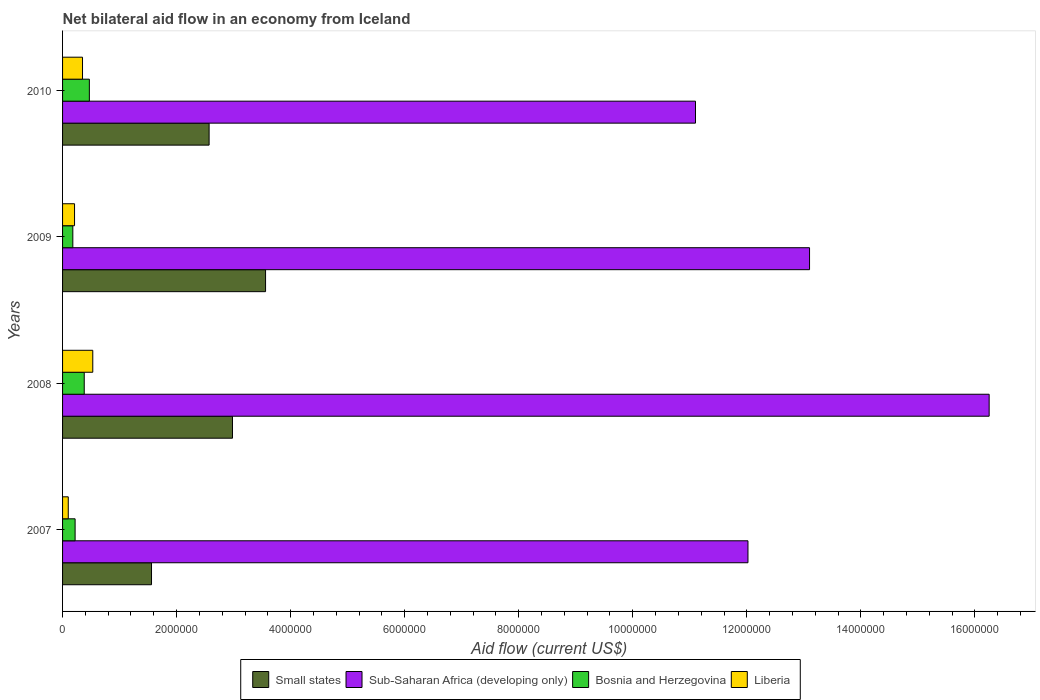How many different coloured bars are there?
Your response must be concise. 4. How many groups of bars are there?
Keep it short and to the point. 4. Are the number of bars per tick equal to the number of legend labels?
Provide a succinct answer. Yes. How many bars are there on the 2nd tick from the bottom?
Provide a short and direct response. 4. What is the net bilateral aid flow in Liberia in 2007?
Keep it short and to the point. 1.00e+05. Across all years, what is the minimum net bilateral aid flow in Sub-Saharan Africa (developing only)?
Your answer should be very brief. 1.11e+07. In which year was the net bilateral aid flow in Bosnia and Herzegovina minimum?
Make the answer very short. 2009. What is the total net bilateral aid flow in Bosnia and Herzegovina in the graph?
Give a very brief answer. 1.25e+06. What is the difference between the net bilateral aid flow in Liberia in 2008 and that in 2009?
Ensure brevity in your answer.  3.20e+05. What is the difference between the net bilateral aid flow in Small states in 2010 and the net bilateral aid flow in Sub-Saharan Africa (developing only) in 2007?
Offer a very short reply. -9.45e+06. What is the average net bilateral aid flow in Small states per year?
Give a very brief answer. 2.67e+06. In the year 2009, what is the difference between the net bilateral aid flow in Sub-Saharan Africa (developing only) and net bilateral aid flow in Bosnia and Herzegovina?
Offer a very short reply. 1.29e+07. In how many years, is the net bilateral aid flow in Small states greater than 10400000 US$?
Offer a terse response. 0. What is the ratio of the net bilateral aid flow in Liberia in 2008 to that in 2009?
Ensure brevity in your answer.  2.52. What is the difference between the highest and the lowest net bilateral aid flow in Sub-Saharan Africa (developing only)?
Offer a very short reply. 5.15e+06. In how many years, is the net bilateral aid flow in Sub-Saharan Africa (developing only) greater than the average net bilateral aid flow in Sub-Saharan Africa (developing only) taken over all years?
Provide a succinct answer. 1. Is it the case that in every year, the sum of the net bilateral aid flow in Liberia and net bilateral aid flow in Small states is greater than the sum of net bilateral aid flow in Bosnia and Herzegovina and net bilateral aid flow in Sub-Saharan Africa (developing only)?
Provide a succinct answer. Yes. What does the 3rd bar from the top in 2010 represents?
Your answer should be compact. Sub-Saharan Africa (developing only). What does the 2nd bar from the bottom in 2009 represents?
Keep it short and to the point. Sub-Saharan Africa (developing only). How many bars are there?
Make the answer very short. 16. Are all the bars in the graph horizontal?
Ensure brevity in your answer.  Yes. How many years are there in the graph?
Ensure brevity in your answer.  4. Are the values on the major ticks of X-axis written in scientific E-notation?
Keep it short and to the point. No. Does the graph contain any zero values?
Make the answer very short. No. Where does the legend appear in the graph?
Your answer should be very brief. Bottom center. What is the title of the graph?
Provide a short and direct response. Net bilateral aid flow in an economy from Iceland. What is the label or title of the Y-axis?
Give a very brief answer. Years. What is the Aid flow (current US$) in Small states in 2007?
Provide a succinct answer. 1.56e+06. What is the Aid flow (current US$) in Sub-Saharan Africa (developing only) in 2007?
Provide a short and direct response. 1.20e+07. What is the Aid flow (current US$) in Bosnia and Herzegovina in 2007?
Offer a terse response. 2.20e+05. What is the Aid flow (current US$) in Small states in 2008?
Keep it short and to the point. 2.98e+06. What is the Aid flow (current US$) of Sub-Saharan Africa (developing only) in 2008?
Provide a succinct answer. 1.62e+07. What is the Aid flow (current US$) in Bosnia and Herzegovina in 2008?
Provide a short and direct response. 3.80e+05. What is the Aid flow (current US$) of Liberia in 2008?
Your answer should be very brief. 5.30e+05. What is the Aid flow (current US$) of Small states in 2009?
Keep it short and to the point. 3.56e+06. What is the Aid flow (current US$) of Sub-Saharan Africa (developing only) in 2009?
Your answer should be compact. 1.31e+07. What is the Aid flow (current US$) in Liberia in 2009?
Your answer should be compact. 2.10e+05. What is the Aid flow (current US$) of Small states in 2010?
Your answer should be compact. 2.57e+06. What is the Aid flow (current US$) in Sub-Saharan Africa (developing only) in 2010?
Offer a very short reply. 1.11e+07. What is the Aid flow (current US$) in Bosnia and Herzegovina in 2010?
Provide a short and direct response. 4.70e+05. What is the Aid flow (current US$) of Liberia in 2010?
Your response must be concise. 3.50e+05. Across all years, what is the maximum Aid flow (current US$) in Small states?
Provide a short and direct response. 3.56e+06. Across all years, what is the maximum Aid flow (current US$) of Sub-Saharan Africa (developing only)?
Your answer should be very brief. 1.62e+07. Across all years, what is the maximum Aid flow (current US$) in Liberia?
Provide a succinct answer. 5.30e+05. Across all years, what is the minimum Aid flow (current US$) in Small states?
Offer a very short reply. 1.56e+06. Across all years, what is the minimum Aid flow (current US$) in Sub-Saharan Africa (developing only)?
Offer a terse response. 1.11e+07. Across all years, what is the minimum Aid flow (current US$) in Bosnia and Herzegovina?
Your answer should be very brief. 1.80e+05. Across all years, what is the minimum Aid flow (current US$) of Liberia?
Provide a short and direct response. 1.00e+05. What is the total Aid flow (current US$) of Small states in the graph?
Your response must be concise. 1.07e+07. What is the total Aid flow (current US$) of Sub-Saharan Africa (developing only) in the graph?
Offer a terse response. 5.25e+07. What is the total Aid flow (current US$) in Bosnia and Herzegovina in the graph?
Provide a short and direct response. 1.25e+06. What is the total Aid flow (current US$) of Liberia in the graph?
Your response must be concise. 1.19e+06. What is the difference between the Aid flow (current US$) of Small states in 2007 and that in 2008?
Your response must be concise. -1.42e+06. What is the difference between the Aid flow (current US$) in Sub-Saharan Africa (developing only) in 2007 and that in 2008?
Your response must be concise. -4.23e+06. What is the difference between the Aid flow (current US$) of Bosnia and Herzegovina in 2007 and that in 2008?
Your response must be concise. -1.60e+05. What is the difference between the Aid flow (current US$) in Liberia in 2007 and that in 2008?
Your response must be concise. -4.30e+05. What is the difference between the Aid flow (current US$) of Sub-Saharan Africa (developing only) in 2007 and that in 2009?
Your response must be concise. -1.08e+06. What is the difference between the Aid flow (current US$) in Liberia in 2007 and that in 2009?
Provide a short and direct response. -1.10e+05. What is the difference between the Aid flow (current US$) in Small states in 2007 and that in 2010?
Your response must be concise. -1.01e+06. What is the difference between the Aid flow (current US$) of Sub-Saharan Africa (developing only) in 2007 and that in 2010?
Make the answer very short. 9.20e+05. What is the difference between the Aid flow (current US$) of Bosnia and Herzegovina in 2007 and that in 2010?
Offer a very short reply. -2.50e+05. What is the difference between the Aid flow (current US$) of Small states in 2008 and that in 2009?
Provide a succinct answer. -5.80e+05. What is the difference between the Aid flow (current US$) of Sub-Saharan Africa (developing only) in 2008 and that in 2009?
Ensure brevity in your answer.  3.15e+06. What is the difference between the Aid flow (current US$) of Sub-Saharan Africa (developing only) in 2008 and that in 2010?
Offer a very short reply. 5.15e+06. What is the difference between the Aid flow (current US$) of Bosnia and Herzegovina in 2008 and that in 2010?
Make the answer very short. -9.00e+04. What is the difference between the Aid flow (current US$) in Small states in 2009 and that in 2010?
Give a very brief answer. 9.90e+05. What is the difference between the Aid flow (current US$) of Sub-Saharan Africa (developing only) in 2009 and that in 2010?
Provide a succinct answer. 2.00e+06. What is the difference between the Aid flow (current US$) in Small states in 2007 and the Aid flow (current US$) in Sub-Saharan Africa (developing only) in 2008?
Give a very brief answer. -1.47e+07. What is the difference between the Aid flow (current US$) in Small states in 2007 and the Aid flow (current US$) in Bosnia and Herzegovina in 2008?
Offer a terse response. 1.18e+06. What is the difference between the Aid flow (current US$) of Small states in 2007 and the Aid flow (current US$) of Liberia in 2008?
Your answer should be compact. 1.03e+06. What is the difference between the Aid flow (current US$) in Sub-Saharan Africa (developing only) in 2007 and the Aid flow (current US$) in Bosnia and Herzegovina in 2008?
Ensure brevity in your answer.  1.16e+07. What is the difference between the Aid flow (current US$) of Sub-Saharan Africa (developing only) in 2007 and the Aid flow (current US$) of Liberia in 2008?
Your answer should be compact. 1.15e+07. What is the difference between the Aid flow (current US$) in Bosnia and Herzegovina in 2007 and the Aid flow (current US$) in Liberia in 2008?
Provide a succinct answer. -3.10e+05. What is the difference between the Aid flow (current US$) in Small states in 2007 and the Aid flow (current US$) in Sub-Saharan Africa (developing only) in 2009?
Your response must be concise. -1.15e+07. What is the difference between the Aid flow (current US$) in Small states in 2007 and the Aid flow (current US$) in Bosnia and Herzegovina in 2009?
Offer a very short reply. 1.38e+06. What is the difference between the Aid flow (current US$) in Small states in 2007 and the Aid flow (current US$) in Liberia in 2009?
Ensure brevity in your answer.  1.35e+06. What is the difference between the Aid flow (current US$) of Sub-Saharan Africa (developing only) in 2007 and the Aid flow (current US$) of Bosnia and Herzegovina in 2009?
Provide a short and direct response. 1.18e+07. What is the difference between the Aid flow (current US$) of Sub-Saharan Africa (developing only) in 2007 and the Aid flow (current US$) of Liberia in 2009?
Provide a short and direct response. 1.18e+07. What is the difference between the Aid flow (current US$) of Bosnia and Herzegovina in 2007 and the Aid flow (current US$) of Liberia in 2009?
Your answer should be very brief. 10000. What is the difference between the Aid flow (current US$) of Small states in 2007 and the Aid flow (current US$) of Sub-Saharan Africa (developing only) in 2010?
Your response must be concise. -9.54e+06. What is the difference between the Aid flow (current US$) of Small states in 2007 and the Aid flow (current US$) of Bosnia and Herzegovina in 2010?
Give a very brief answer. 1.09e+06. What is the difference between the Aid flow (current US$) in Small states in 2007 and the Aid flow (current US$) in Liberia in 2010?
Make the answer very short. 1.21e+06. What is the difference between the Aid flow (current US$) in Sub-Saharan Africa (developing only) in 2007 and the Aid flow (current US$) in Bosnia and Herzegovina in 2010?
Keep it short and to the point. 1.16e+07. What is the difference between the Aid flow (current US$) in Sub-Saharan Africa (developing only) in 2007 and the Aid flow (current US$) in Liberia in 2010?
Make the answer very short. 1.17e+07. What is the difference between the Aid flow (current US$) in Small states in 2008 and the Aid flow (current US$) in Sub-Saharan Africa (developing only) in 2009?
Give a very brief answer. -1.01e+07. What is the difference between the Aid flow (current US$) of Small states in 2008 and the Aid flow (current US$) of Bosnia and Herzegovina in 2009?
Keep it short and to the point. 2.80e+06. What is the difference between the Aid flow (current US$) in Small states in 2008 and the Aid flow (current US$) in Liberia in 2009?
Your answer should be compact. 2.77e+06. What is the difference between the Aid flow (current US$) in Sub-Saharan Africa (developing only) in 2008 and the Aid flow (current US$) in Bosnia and Herzegovina in 2009?
Keep it short and to the point. 1.61e+07. What is the difference between the Aid flow (current US$) in Sub-Saharan Africa (developing only) in 2008 and the Aid flow (current US$) in Liberia in 2009?
Your response must be concise. 1.60e+07. What is the difference between the Aid flow (current US$) of Small states in 2008 and the Aid flow (current US$) of Sub-Saharan Africa (developing only) in 2010?
Offer a terse response. -8.12e+06. What is the difference between the Aid flow (current US$) of Small states in 2008 and the Aid flow (current US$) of Bosnia and Herzegovina in 2010?
Offer a very short reply. 2.51e+06. What is the difference between the Aid flow (current US$) of Small states in 2008 and the Aid flow (current US$) of Liberia in 2010?
Ensure brevity in your answer.  2.63e+06. What is the difference between the Aid flow (current US$) in Sub-Saharan Africa (developing only) in 2008 and the Aid flow (current US$) in Bosnia and Herzegovina in 2010?
Provide a short and direct response. 1.58e+07. What is the difference between the Aid flow (current US$) in Sub-Saharan Africa (developing only) in 2008 and the Aid flow (current US$) in Liberia in 2010?
Give a very brief answer. 1.59e+07. What is the difference between the Aid flow (current US$) of Small states in 2009 and the Aid flow (current US$) of Sub-Saharan Africa (developing only) in 2010?
Give a very brief answer. -7.54e+06. What is the difference between the Aid flow (current US$) in Small states in 2009 and the Aid flow (current US$) in Bosnia and Herzegovina in 2010?
Your answer should be compact. 3.09e+06. What is the difference between the Aid flow (current US$) in Small states in 2009 and the Aid flow (current US$) in Liberia in 2010?
Your answer should be very brief. 3.21e+06. What is the difference between the Aid flow (current US$) in Sub-Saharan Africa (developing only) in 2009 and the Aid flow (current US$) in Bosnia and Herzegovina in 2010?
Provide a short and direct response. 1.26e+07. What is the difference between the Aid flow (current US$) of Sub-Saharan Africa (developing only) in 2009 and the Aid flow (current US$) of Liberia in 2010?
Your answer should be compact. 1.28e+07. What is the average Aid flow (current US$) of Small states per year?
Offer a very short reply. 2.67e+06. What is the average Aid flow (current US$) of Sub-Saharan Africa (developing only) per year?
Keep it short and to the point. 1.31e+07. What is the average Aid flow (current US$) of Bosnia and Herzegovina per year?
Your response must be concise. 3.12e+05. What is the average Aid flow (current US$) in Liberia per year?
Offer a very short reply. 2.98e+05. In the year 2007, what is the difference between the Aid flow (current US$) of Small states and Aid flow (current US$) of Sub-Saharan Africa (developing only)?
Keep it short and to the point. -1.05e+07. In the year 2007, what is the difference between the Aid flow (current US$) of Small states and Aid flow (current US$) of Bosnia and Herzegovina?
Ensure brevity in your answer.  1.34e+06. In the year 2007, what is the difference between the Aid flow (current US$) of Small states and Aid flow (current US$) of Liberia?
Offer a very short reply. 1.46e+06. In the year 2007, what is the difference between the Aid flow (current US$) of Sub-Saharan Africa (developing only) and Aid flow (current US$) of Bosnia and Herzegovina?
Offer a terse response. 1.18e+07. In the year 2007, what is the difference between the Aid flow (current US$) in Sub-Saharan Africa (developing only) and Aid flow (current US$) in Liberia?
Offer a very short reply. 1.19e+07. In the year 2008, what is the difference between the Aid flow (current US$) of Small states and Aid flow (current US$) of Sub-Saharan Africa (developing only)?
Offer a terse response. -1.33e+07. In the year 2008, what is the difference between the Aid flow (current US$) in Small states and Aid flow (current US$) in Bosnia and Herzegovina?
Offer a terse response. 2.60e+06. In the year 2008, what is the difference between the Aid flow (current US$) in Small states and Aid flow (current US$) in Liberia?
Your response must be concise. 2.45e+06. In the year 2008, what is the difference between the Aid flow (current US$) in Sub-Saharan Africa (developing only) and Aid flow (current US$) in Bosnia and Herzegovina?
Make the answer very short. 1.59e+07. In the year 2008, what is the difference between the Aid flow (current US$) in Sub-Saharan Africa (developing only) and Aid flow (current US$) in Liberia?
Offer a very short reply. 1.57e+07. In the year 2008, what is the difference between the Aid flow (current US$) in Bosnia and Herzegovina and Aid flow (current US$) in Liberia?
Offer a terse response. -1.50e+05. In the year 2009, what is the difference between the Aid flow (current US$) of Small states and Aid flow (current US$) of Sub-Saharan Africa (developing only)?
Offer a very short reply. -9.54e+06. In the year 2009, what is the difference between the Aid flow (current US$) in Small states and Aid flow (current US$) in Bosnia and Herzegovina?
Provide a succinct answer. 3.38e+06. In the year 2009, what is the difference between the Aid flow (current US$) of Small states and Aid flow (current US$) of Liberia?
Ensure brevity in your answer.  3.35e+06. In the year 2009, what is the difference between the Aid flow (current US$) of Sub-Saharan Africa (developing only) and Aid flow (current US$) of Bosnia and Herzegovina?
Provide a succinct answer. 1.29e+07. In the year 2009, what is the difference between the Aid flow (current US$) in Sub-Saharan Africa (developing only) and Aid flow (current US$) in Liberia?
Your answer should be very brief. 1.29e+07. In the year 2009, what is the difference between the Aid flow (current US$) of Bosnia and Herzegovina and Aid flow (current US$) of Liberia?
Make the answer very short. -3.00e+04. In the year 2010, what is the difference between the Aid flow (current US$) of Small states and Aid flow (current US$) of Sub-Saharan Africa (developing only)?
Your response must be concise. -8.53e+06. In the year 2010, what is the difference between the Aid flow (current US$) in Small states and Aid flow (current US$) in Bosnia and Herzegovina?
Give a very brief answer. 2.10e+06. In the year 2010, what is the difference between the Aid flow (current US$) in Small states and Aid flow (current US$) in Liberia?
Offer a very short reply. 2.22e+06. In the year 2010, what is the difference between the Aid flow (current US$) of Sub-Saharan Africa (developing only) and Aid flow (current US$) of Bosnia and Herzegovina?
Your answer should be compact. 1.06e+07. In the year 2010, what is the difference between the Aid flow (current US$) of Sub-Saharan Africa (developing only) and Aid flow (current US$) of Liberia?
Offer a terse response. 1.08e+07. What is the ratio of the Aid flow (current US$) of Small states in 2007 to that in 2008?
Keep it short and to the point. 0.52. What is the ratio of the Aid flow (current US$) of Sub-Saharan Africa (developing only) in 2007 to that in 2008?
Offer a terse response. 0.74. What is the ratio of the Aid flow (current US$) in Bosnia and Herzegovina in 2007 to that in 2008?
Your answer should be very brief. 0.58. What is the ratio of the Aid flow (current US$) of Liberia in 2007 to that in 2008?
Provide a short and direct response. 0.19. What is the ratio of the Aid flow (current US$) of Small states in 2007 to that in 2009?
Your answer should be very brief. 0.44. What is the ratio of the Aid flow (current US$) in Sub-Saharan Africa (developing only) in 2007 to that in 2009?
Provide a succinct answer. 0.92. What is the ratio of the Aid flow (current US$) in Bosnia and Herzegovina in 2007 to that in 2009?
Your answer should be very brief. 1.22. What is the ratio of the Aid flow (current US$) in Liberia in 2007 to that in 2009?
Make the answer very short. 0.48. What is the ratio of the Aid flow (current US$) in Small states in 2007 to that in 2010?
Provide a succinct answer. 0.61. What is the ratio of the Aid flow (current US$) of Sub-Saharan Africa (developing only) in 2007 to that in 2010?
Keep it short and to the point. 1.08. What is the ratio of the Aid flow (current US$) of Bosnia and Herzegovina in 2007 to that in 2010?
Ensure brevity in your answer.  0.47. What is the ratio of the Aid flow (current US$) of Liberia in 2007 to that in 2010?
Offer a terse response. 0.29. What is the ratio of the Aid flow (current US$) in Small states in 2008 to that in 2009?
Provide a short and direct response. 0.84. What is the ratio of the Aid flow (current US$) of Sub-Saharan Africa (developing only) in 2008 to that in 2009?
Provide a succinct answer. 1.24. What is the ratio of the Aid flow (current US$) in Bosnia and Herzegovina in 2008 to that in 2009?
Give a very brief answer. 2.11. What is the ratio of the Aid flow (current US$) in Liberia in 2008 to that in 2009?
Your response must be concise. 2.52. What is the ratio of the Aid flow (current US$) in Small states in 2008 to that in 2010?
Give a very brief answer. 1.16. What is the ratio of the Aid flow (current US$) of Sub-Saharan Africa (developing only) in 2008 to that in 2010?
Provide a short and direct response. 1.46. What is the ratio of the Aid flow (current US$) of Bosnia and Herzegovina in 2008 to that in 2010?
Your answer should be compact. 0.81. What is the ratio of the Aid flow (current US$) in Liberia in 2008 to that in 2010?
Offer a terse response. 1.51. What is the ratio of the Aid flow (current US$) of Small states in 2009 to that in 2010?
Your response must be concise. 1.39. What is the ratio of the Aid flow (current US$) in Sub-Saharan Africa (developing only) in 2009 to that in 2010?
Ensure brevity in your answer.  1.18. What is the ratio of the Aid flow (current US$) of Bosnia and Herzegovina in 2009 to that in 2010?
Make the answer very short. 0.38. What is the difference between the highest and the second highest Aid flow (current US$) of Small states?
Ensure brevity in your answer.  5.80e+05. What is the difference between the highest and the second highest Aid flow (current US$) in Sub-Saharan Africa (developing only)?
Ensure brevity in your answer.  3.15e+06. What is the difference between the highest and the second highest Aid flow (current US$) in Bosnia and Herzegovina?
Your answer should be very brief. 9.00e+04. What is the difference between the highest and the lowest Aid flow (current US$) of Sub-Saharan Africa (developing only)?
Provide a short and direct response. 5.15e+06. 